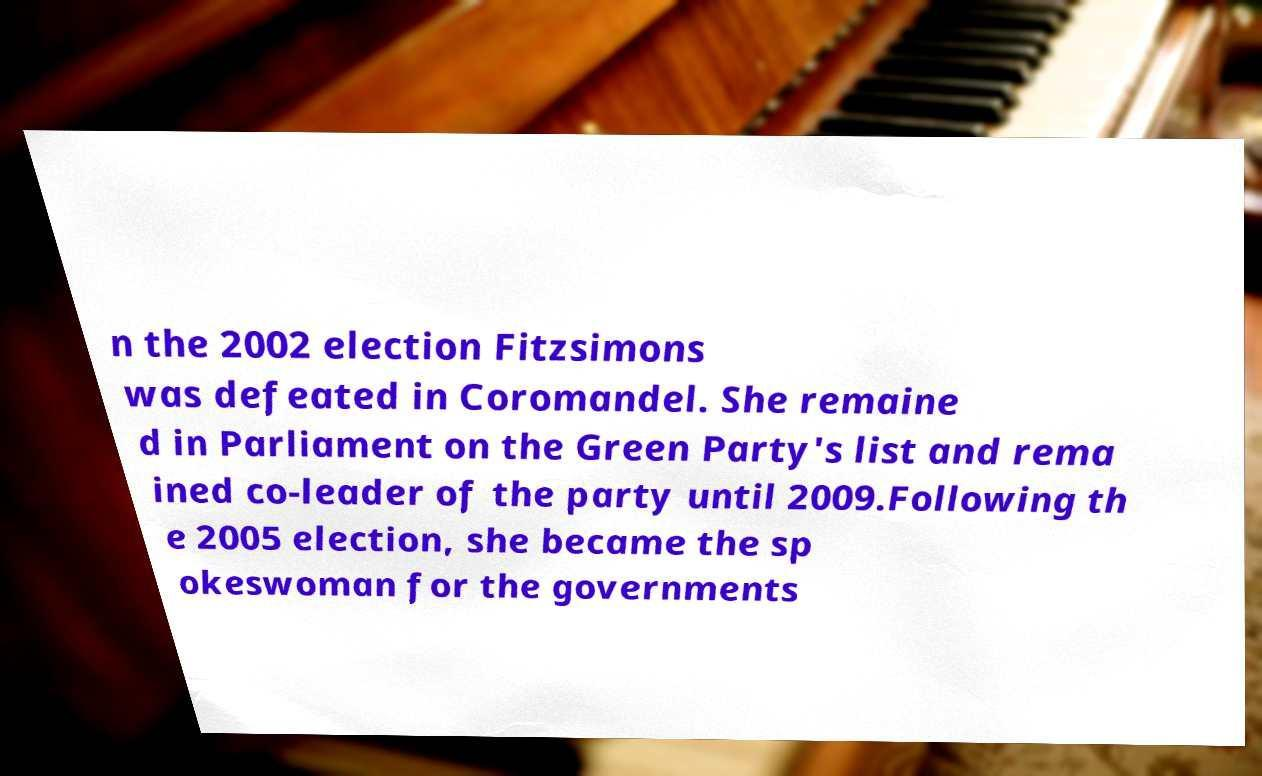Please read and relay the text visible in this image. What does it say? n the 2002 election Fitzsimons was defeated in Coromandel. She remaine d in Parliament on the Green Party's list and rema ined co-leader of the party until 2009.Following th e 2005 election, she became the sp okeswoman for the governments 